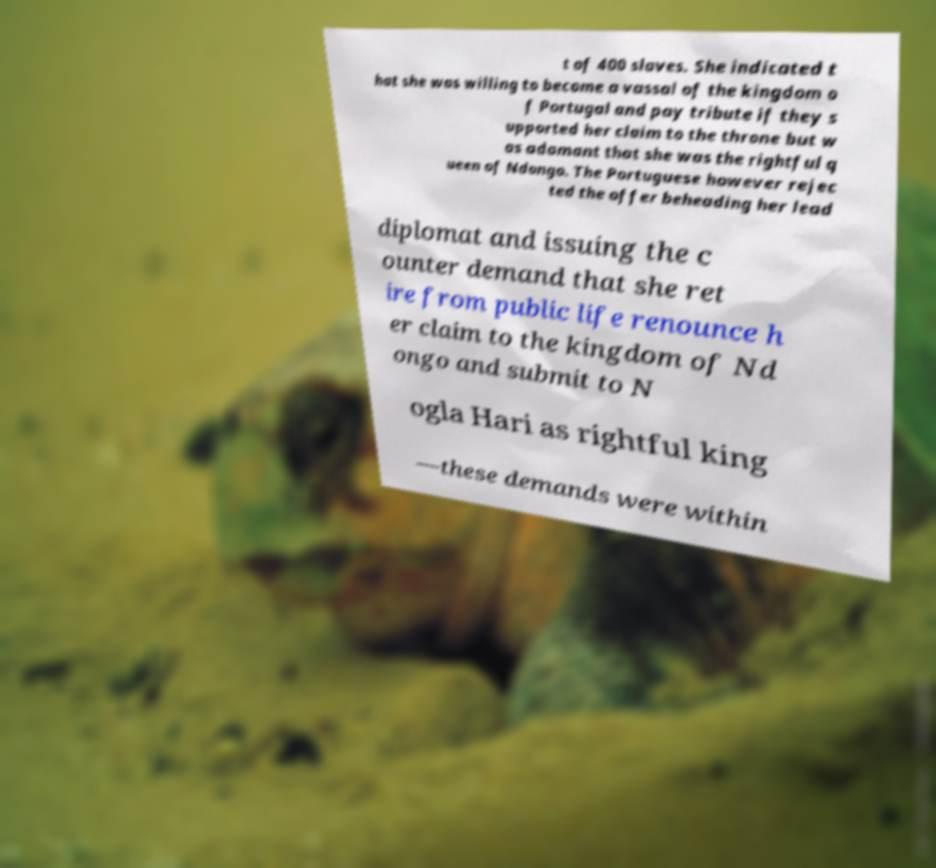Can you read and provide the text displayed in the image?This photo seems to have some interesting text. Can you extract and type it out for me? t of 400 slaves. She indicated t hat she was willing to become a vassal of the kingdom o f Portugal and pay tribute if they s upported her claim to the throne but w as adamant that she was the rightful q ueen of Ndongo. The Portuguese however rejec ted the offer beheading her lead diplomat and issuing the c ounter demand that she ret ire from public life renounce h er claim to the kingdom of Nd ongo and submit to N ogla Hari as rightful king —these demands were within 